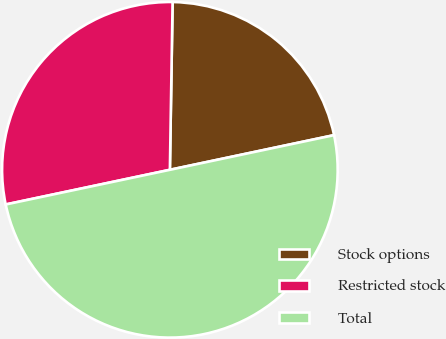<chart> <loc_0><loc_0><loc_500><loc_500><pie_chart><fcel>Stock options<fcel>Restricted stock<fcel>Total<nl><fcel>21.43%<fcel>28.57%<fcel>50.0%<nl></chart> 